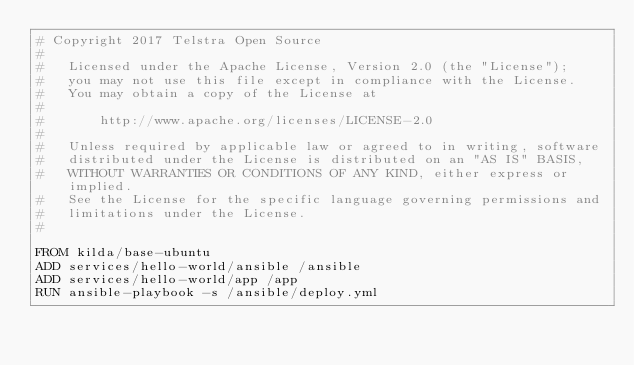Convert code to text. <code><loc_0><loc_0><loc_500><loc_500><_Dockerfile_># Copyright 2017 Telstra Open Source
#
#   Licensed under the Apache License, Version 2.0 (the "License");
#   you may not use this file except in compliance with the License.
#   You may obtain a copy of the License at
#
#       http://www.apache.org/licenses/LICENSE-2.0
#
#   Unless required by applicable law or agreed to in writing, software
#   distributed under the License is distributed on an "AS IS" BASIS,
#   WITHOUT WARRANTIES OR CONDITIONS OF ANY KIND, either express or implied.
#   See the License for the specific language governing permissions and
#   limitations under the License.
#

FROM kilda/base-ubuntu
ADD services/hello-world/ansible /ansible
ADD services/hello-world/app /app
RUN ansible-playbook -s /ansible/deploy.yml
</code> 